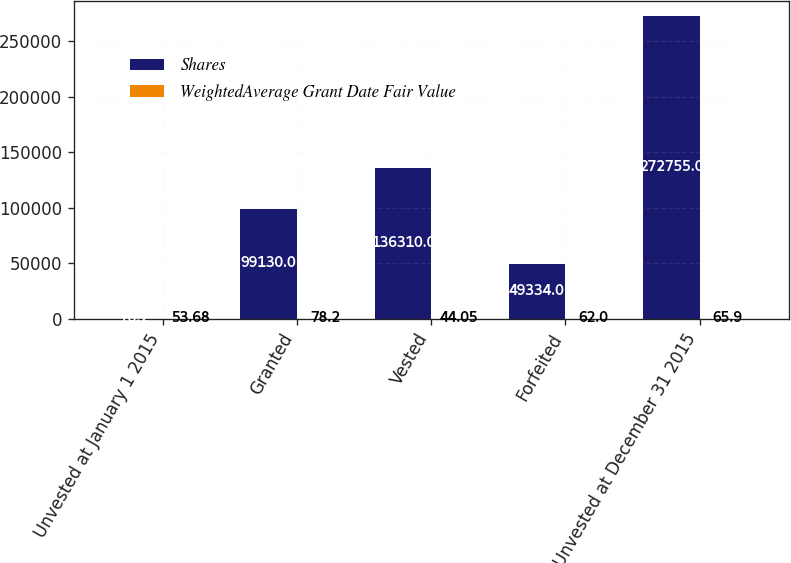Convert chart to OTSL. <chart><loc_0><loc_0><loc_500><loc_500><stacked_bar_chart><ecel><fcel>Unvested at January 1 2015<fcel>Granted<fcel>Vested<fcel>Forfeited<fcel>Unvested at December 31 2015<nl><fcel>Shares<fcel>78.2<fcel>99130<fcel>136310<fcel>49334<fcel>272755<nl><fcel>WeightedAverage Grant Date Fair Value<fcel>53.68<fcel>78.2<fcel>44.05<fcel>62<fcel>65.9<nl></chart> 